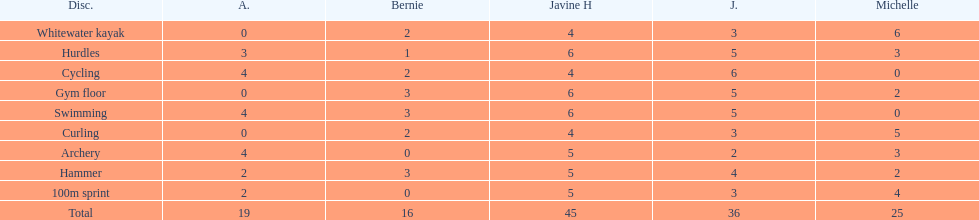In the hurdles, what was bernie's point tally? 1. 